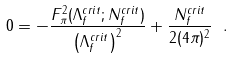<formula> <loc_0><loc_0><loc_500><loc_500>0 = - \frac { F _ { \pi } ^ { 2 } ( \Lambda _ { f } ^ { c r i t } ; N _ { f } ^ { c r i t } ) } { \left ( \Lambda _ { f } ^ { c r i t } \right ) ^ { 2 } } + \frac { N _ { f } ^ { c r i t } } { 2 ( 4 \pi ) ^ { 2 } } \ .</formula> 